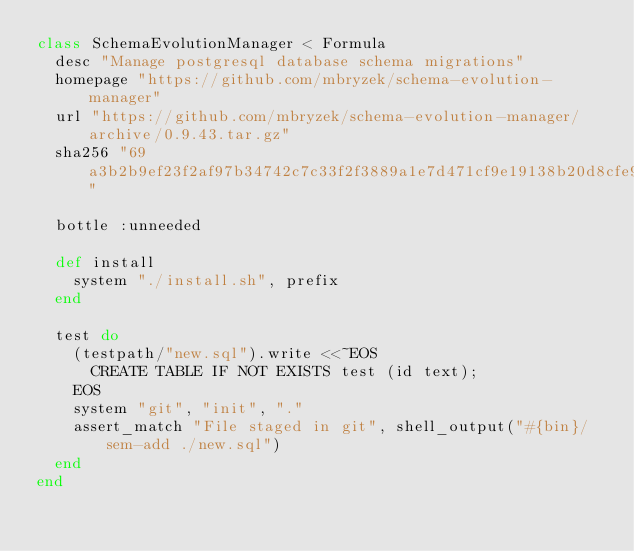<code> <loc_0><loc_0><loc_500><loc_500><_Ruby_>class SchemaEvolutionManager < Formula
  desc "Manage postgresql database schema migrations"
  homepage "https://github.com/mbryzek/schema-evolution-manager"
  url "https://github.com/mbryzek/schema-evolution-manager/archive/0.9.43.tar.gz"
  sha256 "69a3b2b9ef23f2af97b34742c7c33f2f3889a1e7d471cf9e19138b20d8cfe944"

  bottle :unneeded

  def install
    system "./install.sh", prefix
  end

  test do
    (testpath/"new.sql").write <<~EOS
      CREATE TABLE IF NOT EXISTS test (id text);
    EOS
    system "git", "init", "."
    assert_match "File staged in git", shell_output("#{bin}/sem-add ./new.sql")
  end
end
</code> 